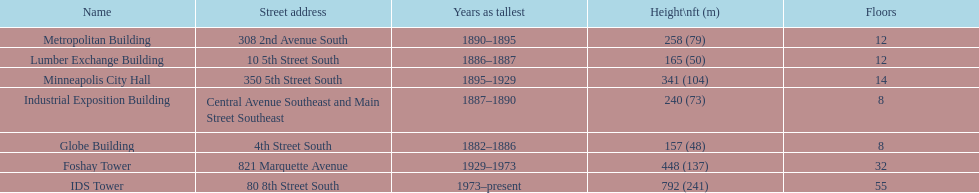Name the tallest building. IDS Tower. Would you be able to parse every entry in this table? {'header': ['Name', 'Street address', 'Years as tallest', 'Height\\nft (m)', 'Floors'], 'rows': [['Metropolitan Building', '308 2nd Avenue South', '1890–1895', '258 (79)', '12'], ['Lumber Exchange Building', '10 5th Street South', '1886–1887', '165 (50)', '12'], ['Minneapolis City Hall', '350 5th Street South', '1895–1929', '341 (104)', '14'], ['Industrial Exposition Building', 'Central Avenue Southeast and Main Street Southeast', '1887–1890', '240 (73)', '8'], ['Globe Building', '4th Street South', '1882–1886', '157 (48)', '8'], ['Foshay Tower', '821 Marquette Avenue', '1929–1973', '448 (137)', '32'], ['IDS Tower', '80 8th Street South', '1973–present', '792 (241)', '55']]} 